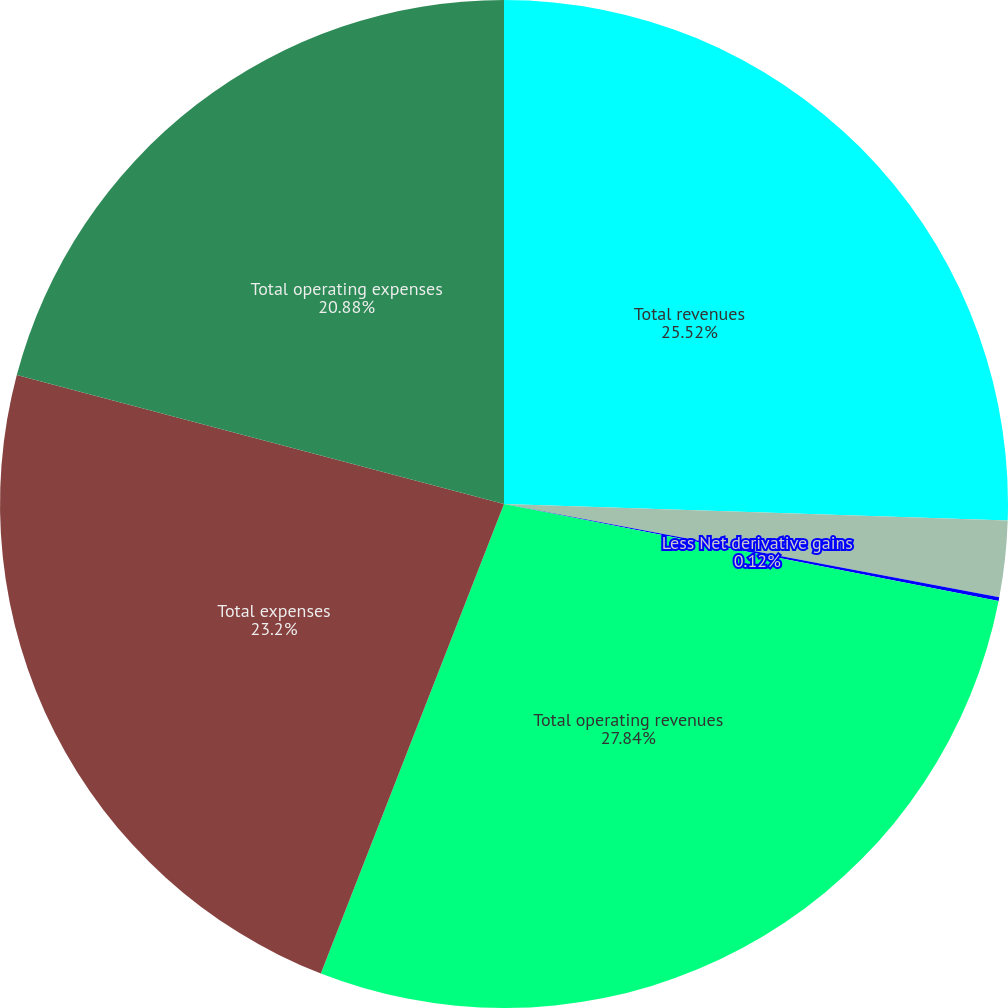Convert chart to OTSL. <chart><loc_0><loc_0><loc_500><loc_500><pie_chart><fcel>Total revenues<fcel>Less Net investment gains<fcel>Less Net derivative gains<fcel>Total operating revenues<fcel>Total expenses<fcel>Total operating expenses<nl><fcel>25.52%<fcel>2.44%<fcel>0.12%<fcel>27.84%<fcel>23.2%<fcel>20.88%<nl></chart> 